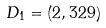<formula> <loc_0><loc_0><loc_500><loc_500>D _ { 1 } = ( 2 , 3 2 9 )</formula> 